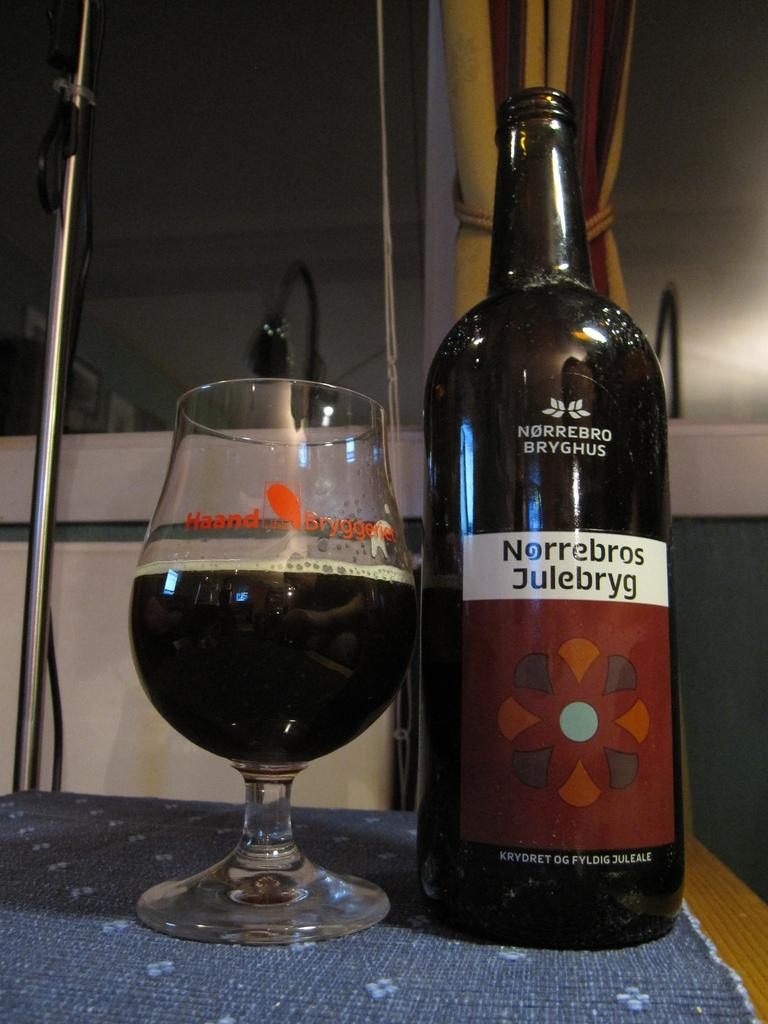<image>
Provide a brief description of the given image. A bottle has Norrebros Julebryg on the label and a glass next to it. 